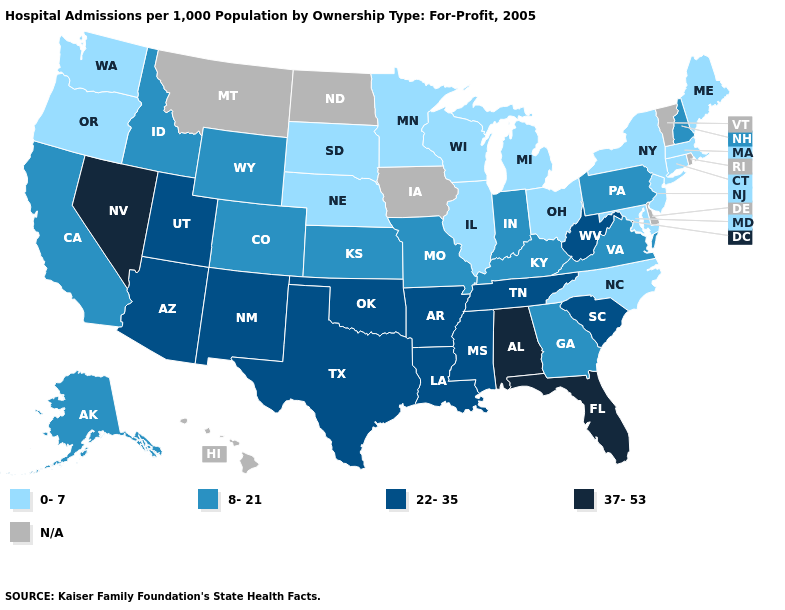Which states have the lowest value in the USA?
Keep it brief. Connecticut, Illinois, Maine, Maryland, Massachusetts, Michigan, Minnesota, Nebraska, New Jersey, New York, North Carolina, Ohio, Oregon, South Dakota, Washington, Wisconsin. What is the value of New Hampshire?
Keep it brief. 8-21. Does Alabama have the highest value in the USA?
Give a very brief answer. Yes. Name the states that have a value in the range 0-7?
Keep it brief. Connecticut, Illinois, Maine, Maryland, Massachusetts, Michigan, Minnesota, Nebraska, New Jersey, New York, North Carolina, Ohio, Oregon, South Dakota, Washington, Wisconsin. What is the value of New Hampshire?
Concise answer only. 8-21. What is the value of Texas?
Be succinct. 22-35. Does the map have missing data?
Concise answer only. Yes. Name the states that have a value in the range 37-53?
Concise answer only. Alabama, Florida, Nevada. What is the lowest value in the Northeast?
Write a very short answer. 0-7. Which states have the lowest value in the South?
Give a very brief answer. Maryland, North Carolina. What is the value of Wyoming?
Write a very short answer. 8-21. What is the value of Pennsylvania?
Be succinct. 8-21. Among the states that border Wisconsin , which have the highest value?
Short answer required. Illinois, Michigan, Minnesota. Is the legend a continuous bar?
Give a very brief answer. No. 